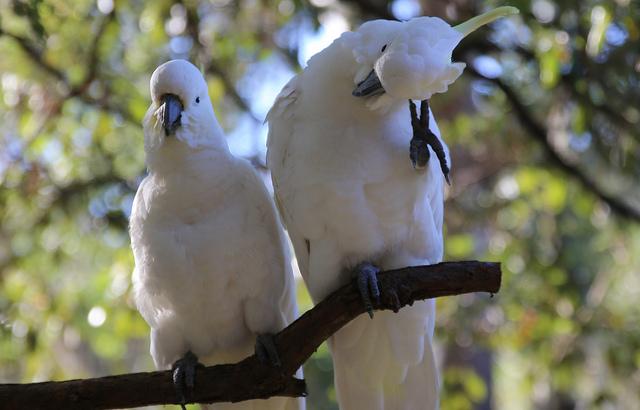How many birds are there?
Give a very brief answer. 2. Are these Macaws?
Write a very short answer. Yes. Which animal is itching?
Be succinct. Right. 